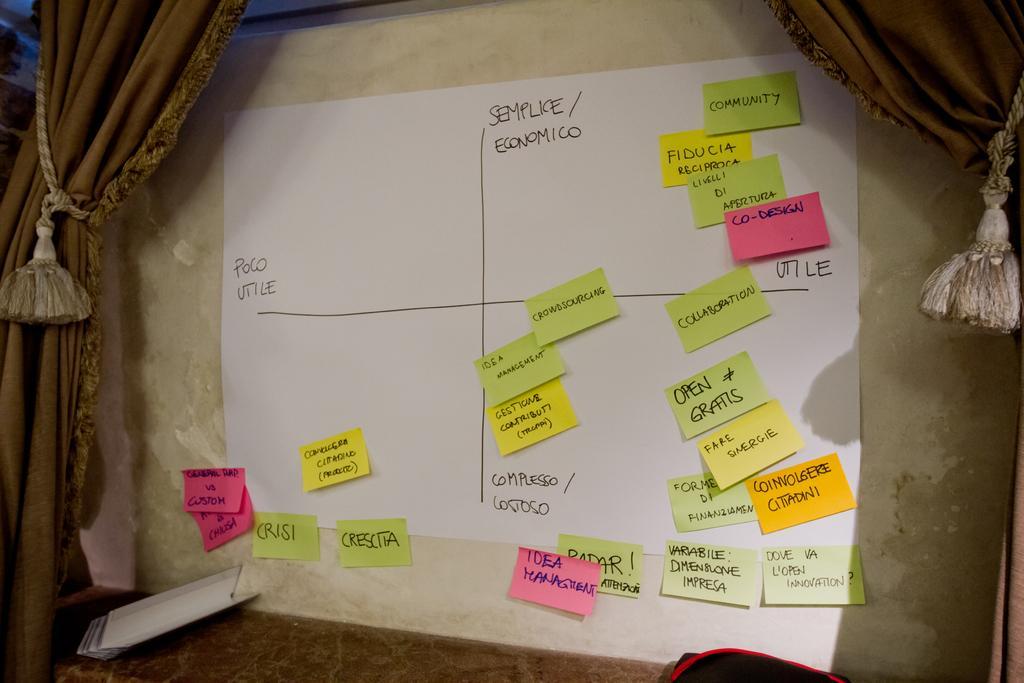Please provide a concise description of this image. In this image we can see a paper is attached to the wall with some different color paper on it and some text is written on the papers. Both side of the image brown color curtain is present. 